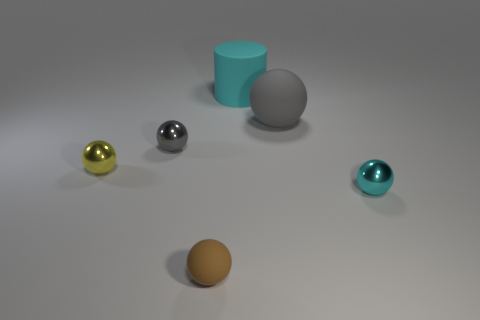Add 3 big gray things. How many objects exist? 9 Subtract all red cylinders. How many gray balls are left? 2 Subtract all tiny matte balls. How many balls are left? 4 Subtract all brown spheres. How many spheres are left? 4 Subtract all balls. How many objects are left? 1 Add 3 small metal objects. How many small metal objects are left? 6 Add 1 small blue shiny objects. How many small blue shiny objects exist? 1 Subtract 0 purple cylinders. How many objects are left? 6 Subtract all green spheres. Subtract all gray blocks. How many spheres are left? 5 Subtract all big blue cubes. Subtract all cylinders. How many objects are left? 5 